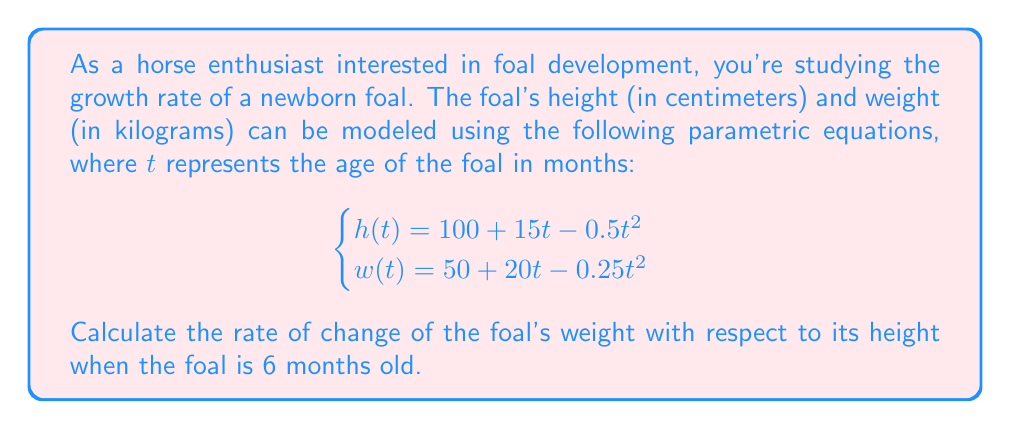Teach me how to tackle this problem. To solve this problem, we'll follow these steps:

1) First, we need to find $\frac{dw}{dt}$ and $\frac{dh}{dt}$ by differentiating the given equations with respect to $t$:

   $$\frac{dh}{dt} = 15 - t$$
   $$\frac{dw}{dt} = 20 - 0.5t$$

2) The rate of change of weight with respect to height is given by $\frac{dw}{dh}$. We can use the chain rule to express this as:

   $$\frac{dw}{dh} = \frac{dw/dt}{dh/dt}$$

3) Now, we substitute $t = 6$ (since the foal is 6 months old) into our derivatives:

   At $t = 6$:
   $$\frac{dh}{dt} = 15 - 6 = 9$$
   $$\frac{dw}{dt} = 20 - 0.5(6) = 17$$

4) Finally, we can calculate $\frac{dw}{dh}$:

   $$\frac{dw}{dh} = \frac{dw/dt}{dh/dt} = \frac{17}{9}$$

This result means that when the foal is 6 months old, its weight is increasing at a rate of $\frac{17}{9}$ kg per cm of height increase.
Answer: $\frac{17}{9}$ kg/cm 